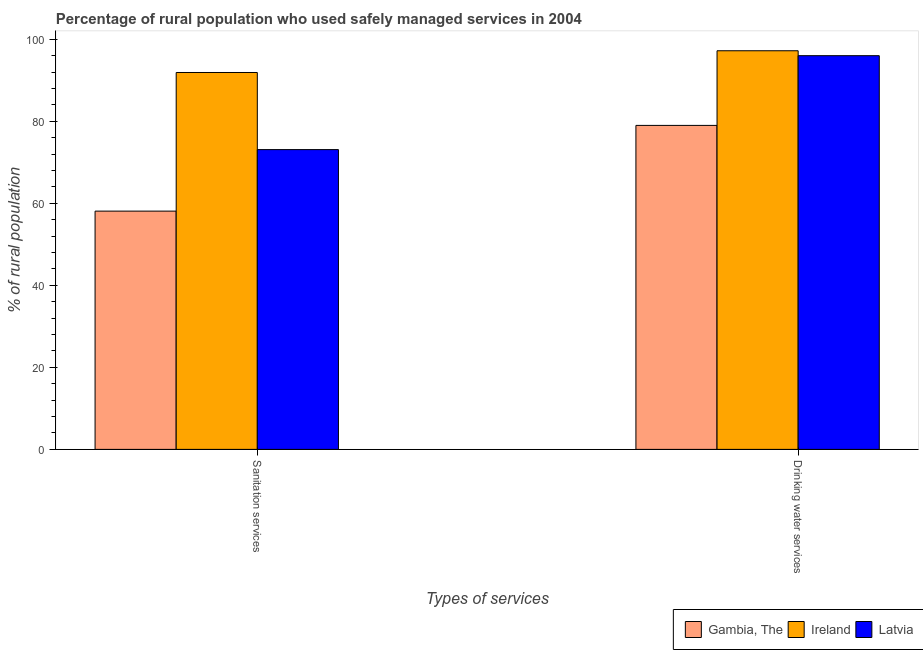How many different coloured bars are there?
Keep it short and to the point. 3. How many groups of bars are there?
Give a very brief answer. 2. What is the label of the 1st group of bars from the left?
Provide a succinct answer. Sanitation services. What is the percentage of rural population who used sanitation services in Gambia, The?
Keep it short and to the point. 58.1. Across all countries, what is the maximum percentage of rural population who used sanitation services?
Keep it short and to the point. 91.9. Across all countries, what is the minimum percentage of rural population who used sanitation services?
Your response must be concise. 58.1. In which country was the percentage of rural population who used sanitation services maximum?
Keep it short and to the point. Ireland. In which country was the percentage of rural population who used sanitation services minimum?
Give a very brief answer. Gambia, The. What is the total percentage of rural population who used drinking water services in the graph?
Give a very brief answer. 272.2. What is the difference between the percentage of rural population who used sanitation services in Latvia and that in Ireland?
Keep it short and to the point. -18.8. What is the difference between the percentage of rural population who used drinking water services in Latvia and the percentage of rural population who used sanitation services in Ireland?
Provide a short and direct response. 4.1. What is the average percentage of rural population who used drinking water services per country?
Your answer should be compact. 90.73. What is the difference between the percentage of rural population who used drinking water services and percentage of rural population who used sanitation services in Latvia?
Provide a succinct answer. 22.9. In how many countries, is the percentage of rural population who used drinking water services greater than 40 %?
Give a very brief answer. 3. What is the ratio of the percentage of rural population who used sanitation services in Ireland to that in Gambia, The?
Offer a terse response. 1.58. What does the 3rd bar from the left in Sanitation services represents?
Your answer should be very brief. Latvia. What does the 2nd bar from the right in Sanitation services represents?
Ensure brevity in your answer.  Ireland. How many bars are there?
Ensure brevity in your answer.  6. Are all the bars in the graph horizontal?
Give a very brief answer. No. Does the graph contain grids?
Give a very brief answer. No. Where does the legend appear in the graph?
Give a very brief answer. Bottom right. How are the legend labels stacked?
Offer a terse response. Horizontal. What is the title of the graph?
Provide a short and direct response. Percentage of rural population who used safely managed services in 2004. Does "St. Kitts and Nevis" appear as one of the legend labels in the graph?
Provide a succinct answer. No. What is the label or title of the X-axis?
Make the answer very short. Types of services. What is the label or title of the Y-axis?
Make the answer very short. % of rural population. What is the % of rural population in Gambia, The in Sanitation services?
Offer a very short reply. 58.1. What is the % of rural population of Ireland in Sanitation services?
Ensure brevity in your answer.  91.9. What is the % of rural population in Latvia in Sanitation services?
Your response must be concise. 73.1. What is the % of rural population of Gambia, The in Drinking water services?
Keep it short and to the point. 79. What is the % of rural population in Ireland in Drinking water services?
Your answer should be compact. 97.2. What is the % of rural population of Latvia in Drinking water services?
Your answer should be very brief. 96. Across all Types of services, what is the maximum % of rural population in Gambia, The?
Your answer should be very brief. 79. Across all Types of services, what is the maximum % of rural population of Ireland?
Your answer should be very brief. 97.2. Across all Types of services, what is the maximum % of rural population of Latvia?
Give a very brief answer. 96. Across all Types of services, what is the minimum % of rural population in Gambia, The?
Offer a very short reply. 58.1. Across all Types of services, what is the minimum % of rural population in Ireland?
Provide a succinct answer. 91.9. Across all Types of services, what is the minimum % of rural population in Latvia?
Ensure brevity in your answer.  73.1. What is the total % of rural population in Gambia, The in the graph?
Your response must be concise. 137.1. What is the total % of rural population of Ireland in the graph?
Your response must be concise. 189.1. What is the total % of rural population in Latvia in the graph?
Keep it short and to the point. 169.1. What is the difference between the % of rural population in Gambia, The in Sanitation services and that in Drinking water services?
Ensure brevity in your answer.  -20.9. What is the difference between the % of rural population in Latvia in Sanitation services and that in Drinking water services?
Your response must be concise. -22.9. What is the difference between the % of rural population in Gambia, The in Sanitation services and the % of rural population in Ireland in Drinking water services?
Your answer should be very brief. -39.1. What is the difference between the % of rural population in Gambia, The in Sanitation services and the % of rural population in Latvia in Drinking water services?
Make the answer very short. -37.9. What is the average % of rural population in Gambia, The per Types of services?
Keep it short and to the point. 68.55. What is the average % of rural population of Ireland per Types of services?
Keep it short and to the point. 94.55. What is the average % of rural population of Latvia per Types of services?
Your answer should be very brief. 84.55. What is the difference between the % of rural population in Gambia, The and % of rural population in Ireland in Sanitation services?
Your answer should be compact. -33.8. What is the difference between the % of rural population in Ireland and % of rural population in Latvia in Sanitation services?
Provide a short and direct response. 18.8. What is the difference between the % of rural population in Gambia, The and % of rural population in Ireland in Drinking water services?
Offer a terse response. -18.2. What is the difference between the % of rural population of Gambia, The and % of rural population of Latvia in Drinking water services?
Your response must be concise. -17. What is the difference between the % of rural population in Ireland and % of rural population in Latvia in Drinking water services?
Keep it short and to the point. 1.2. What is the ratio of the % of rural population in Gambia, The in Sanitation services to that in Drinking water services?
Offer a terse response. 0.74. What is the ratio of the % of rural population of Ireland in Sanitation services to that in Drinking water services?
Keep it short and to the point. 0.95. What is the ratio of the % of rural population of Latvia in Sanitation services to that in Drinking water services?
Offer a terse response. 0.76. What is the difference between the highest and the second highest % of rural population of Gambia, The?
Provide a succinct answer. 20.9. What is the difference between the highest and the second highest % of rural population of Ireland?
Provide a succinct answer. 5.3. What is the difference between the highest and the second highest % of rural population of Latvia?
Provide a succinct answer. 22.9. What is the difference between the highest and the lowest % of rural population in Gambia, The?
Provide a succinct answer. 20.9. What is the difference between the highest and the lowest % of rural population of Ireland?
Offer a very short reply. 5.3. What is the difference between the highest and the lowest % of rural population in Latvia?
Offer a terse response. 22.9. 